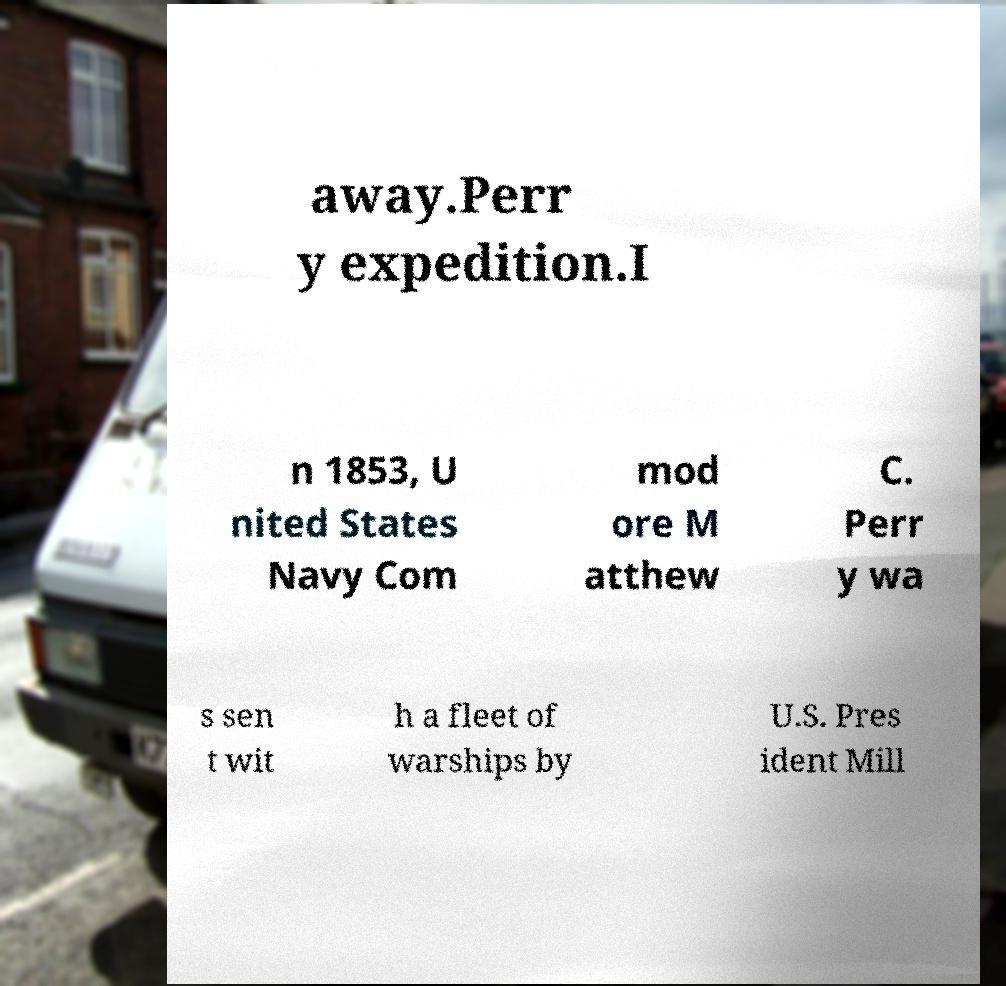Please identify and transcribe the text found in this image. away.Perr y expedition.I n 1853, U nited States Navy Com mod ore M atthew C. Perr y wa s sen t wit h a fleet of warships by U.S. Pres ident Mill 